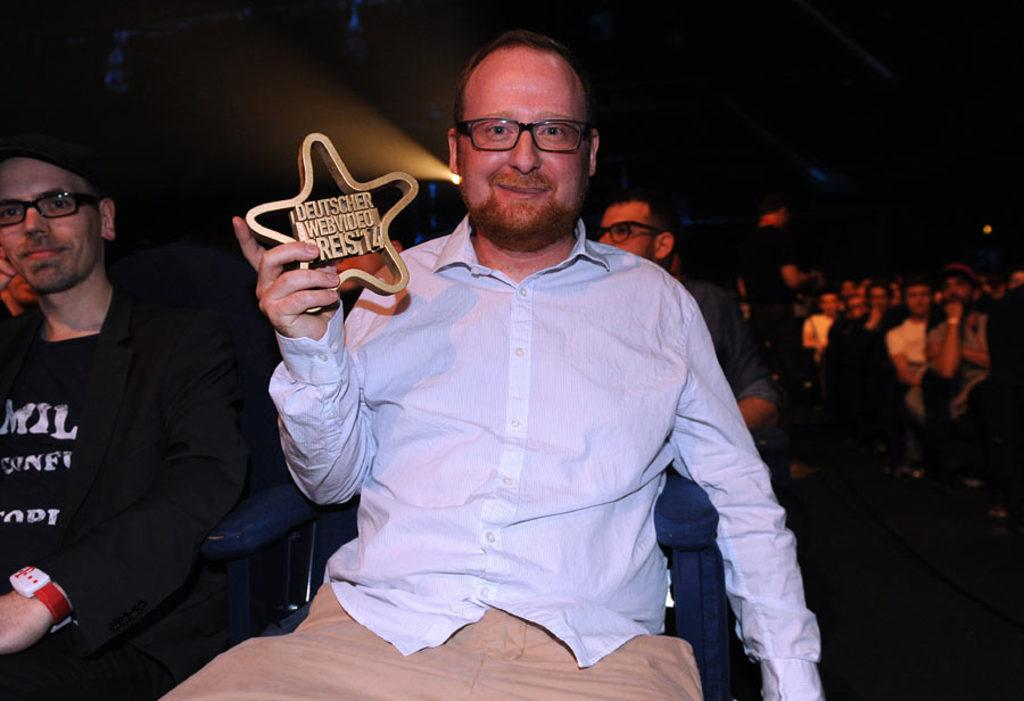How many people are in the image? There are people in the image, but the exact number is not specified. What are some of the people in the image doing? Some people are sitting in the image. What is a person holding in the image? A person is holding an object in the image. What can be seen beneath the people in the image? The ground is visible in the image. What is visible above the people in the image? The roof is visible in the image. What type of circle can be seen in the image? There is no circle present in the image. What does the person holding the object hope to achieve? The facts provided do not give any information about the person's hopes or intentions, so we cannot answer this question. 